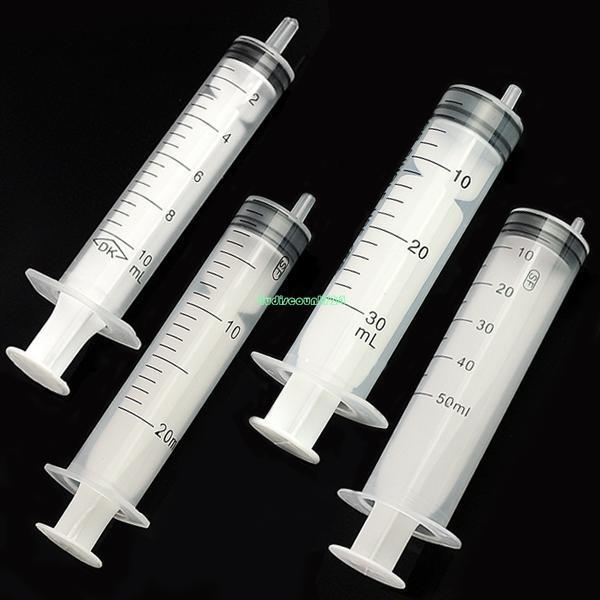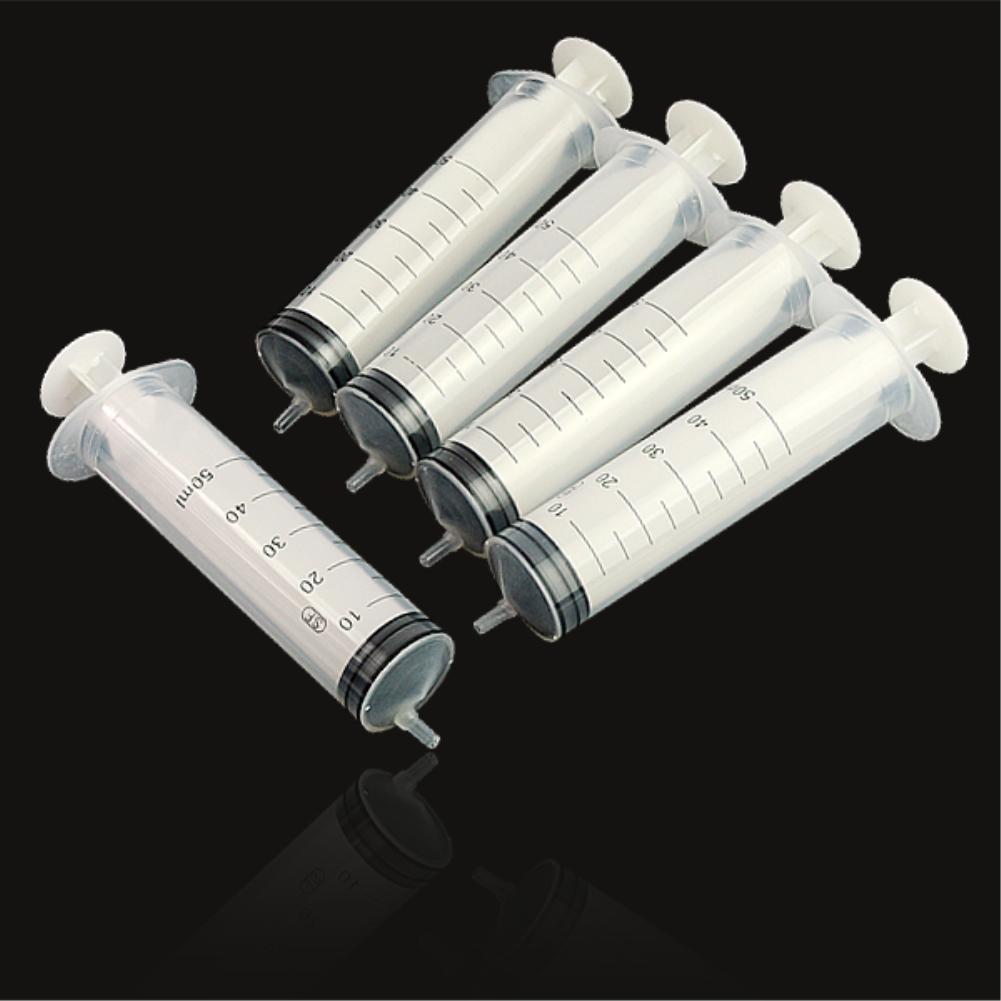The first image is the image on the left, the second image is the image on the right. For the images displayed, is the sentence "In at least one image there is a single empty needle laying down." factually correct? Answer yes or no. No. The first image is the image on the left, the second image is the image on the right. Examine the images to the left and right. Is the description "At least one image contains exactly four syringes, and no image contains less than four syringes." accurate? Answer yes or no. Yes. 